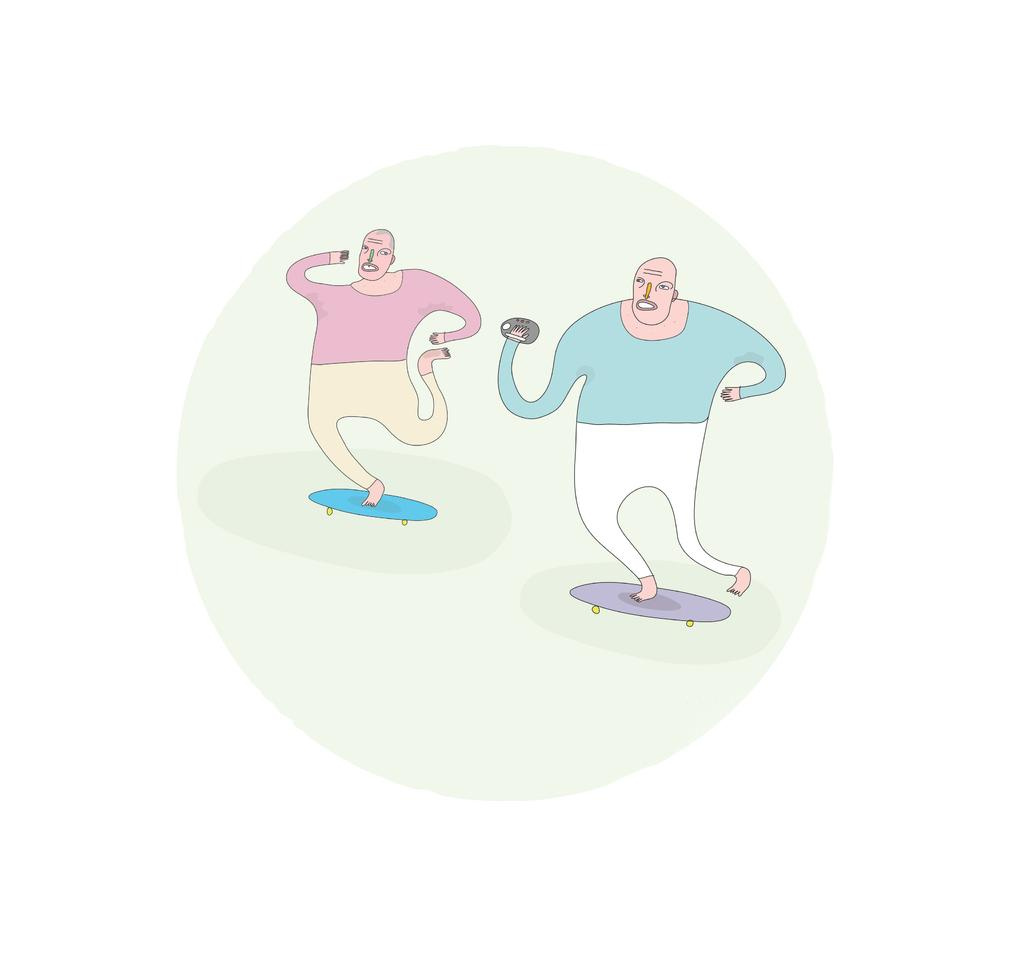What can be seen in the image? There are depictions of persons in the image. What are the persons doing in the image? The persons are on a skateboard. Are the persons wearing masks in the image? There is no mention of masks in the image, so it cannot be determined if the persons are wearing them. 